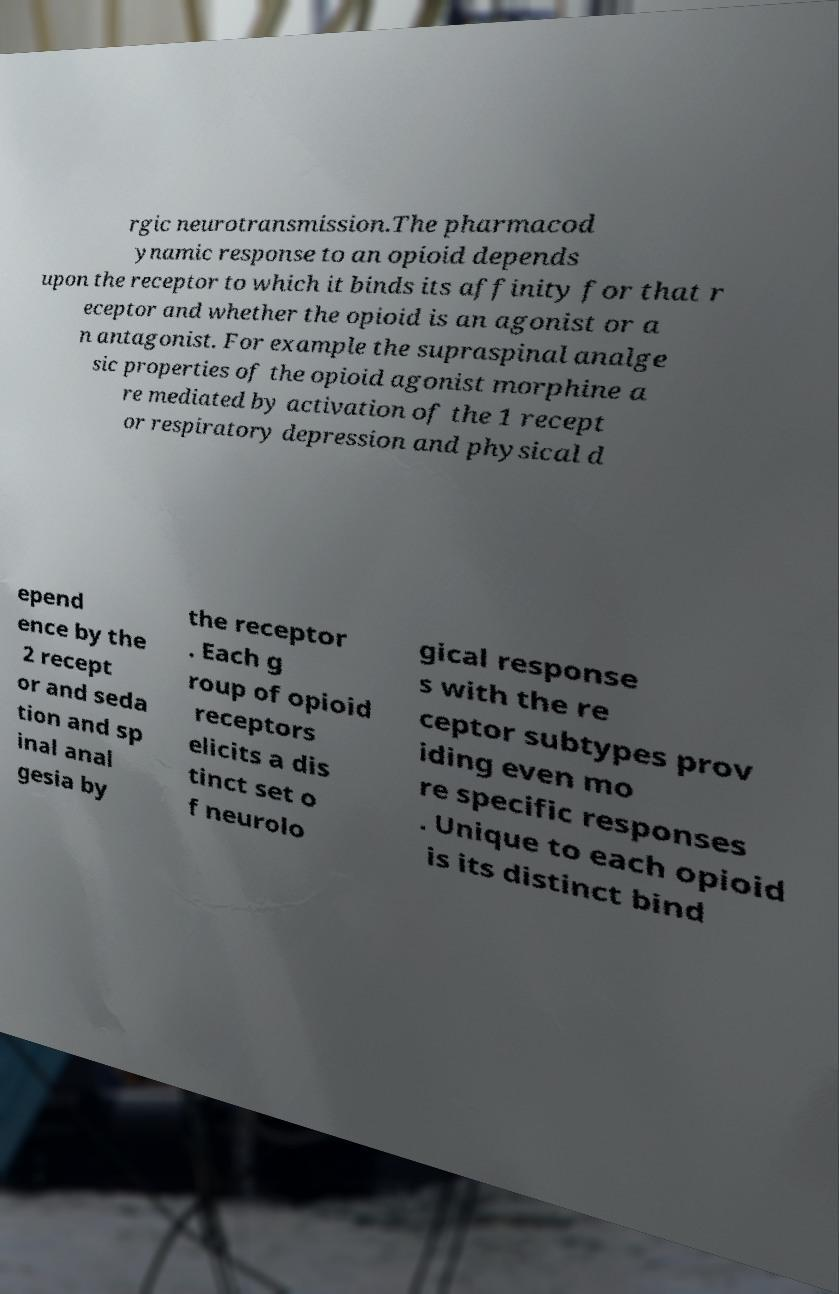Could you extract and type out the text from this image? rgic neurotransmission.The pharmacod ynamic response to an opioid depends upon the receptor to which it binds its affinity for that r eceptor and whether the opioid is an agonist or a n antagonist. For example the supraspinal analge sic properties of the opioid agonist morphine a re mediated by activation of the 1 recept or respiratory depression and physical d epend ence by the 2 recept or and seda tion and sp inal anal gesia by the receptor . Each g roup of opioid receptors elicits a dis tinct set o f neurolo gical response s with the re ceptor subtypes prov iding even mo re specific responses . Unique to each opioid is its distinct bind 